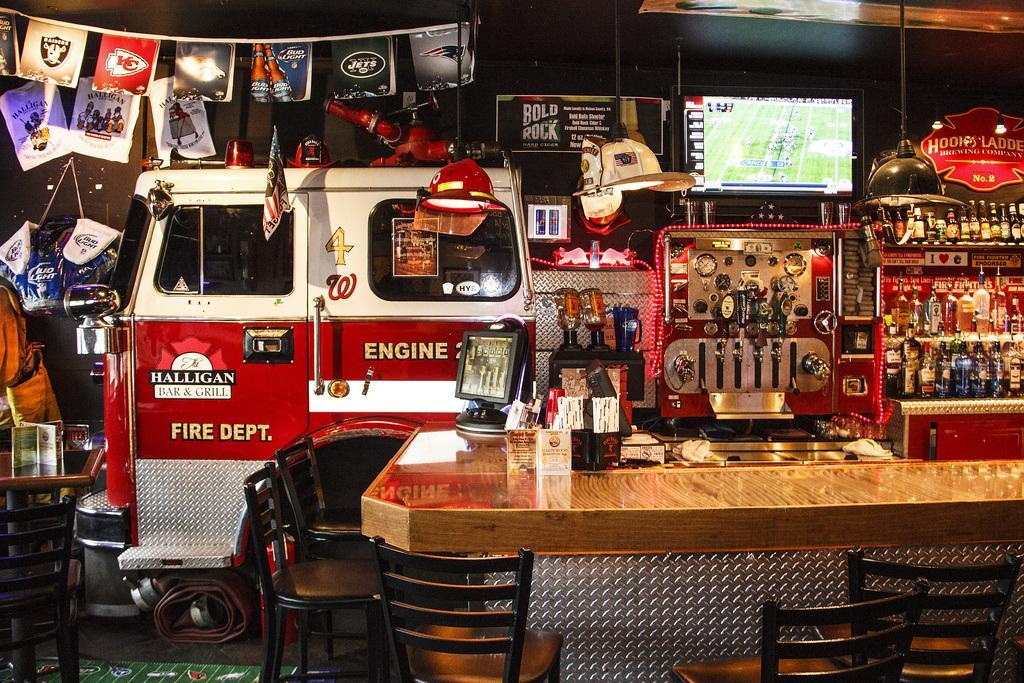How would you summarize this image in a sentence or two? In this image there is one table and some chairs, and on the table there is a photo frame, box and some other objects. And in the background there are some bottles, television, light and some instruments, vehicle door and some other objects. And on the left side there are some flags, posters, papers, chair and some objects and under the vehicle there is one cover. At the bottom there is floor. 